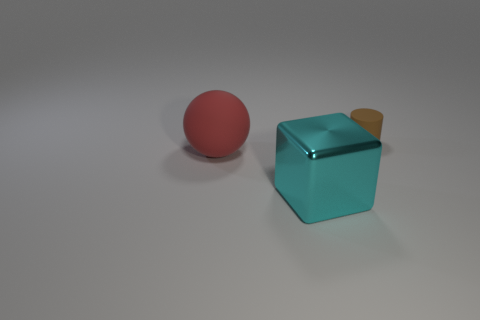Are there any other things that are the same size as the rubber cylinder?
Your answer should be very brief. No. How many big red rubber objects have the same shape as the brown rubber object?
Your response must be concise. 0. What shape is the big matte object?
Give a very brief answer. Sphere. There is a thing that is in front of the matte thing that is to the left of the block; how big is it?
Offer a terse response. Large. What number of objects are either tiny gray matte balls or rubber objects?
Give a very brief answer. 2. Are there any gray balls made of the same material as the big cube?
Keep it short and to the point. No. Is there a tiny brown cylinder in front of the small thing behind the large red thing?
Keep it short and to the point. No. Is the size of the rubber object to the left of the cylinder the same as the big metallic thing?
Give a very brief answer. Yes. How big is the red thing?
Offer a very short reply. Large. Is there a big shiny cube of the same color as the large matte thing?
Make the answer very short. No. 